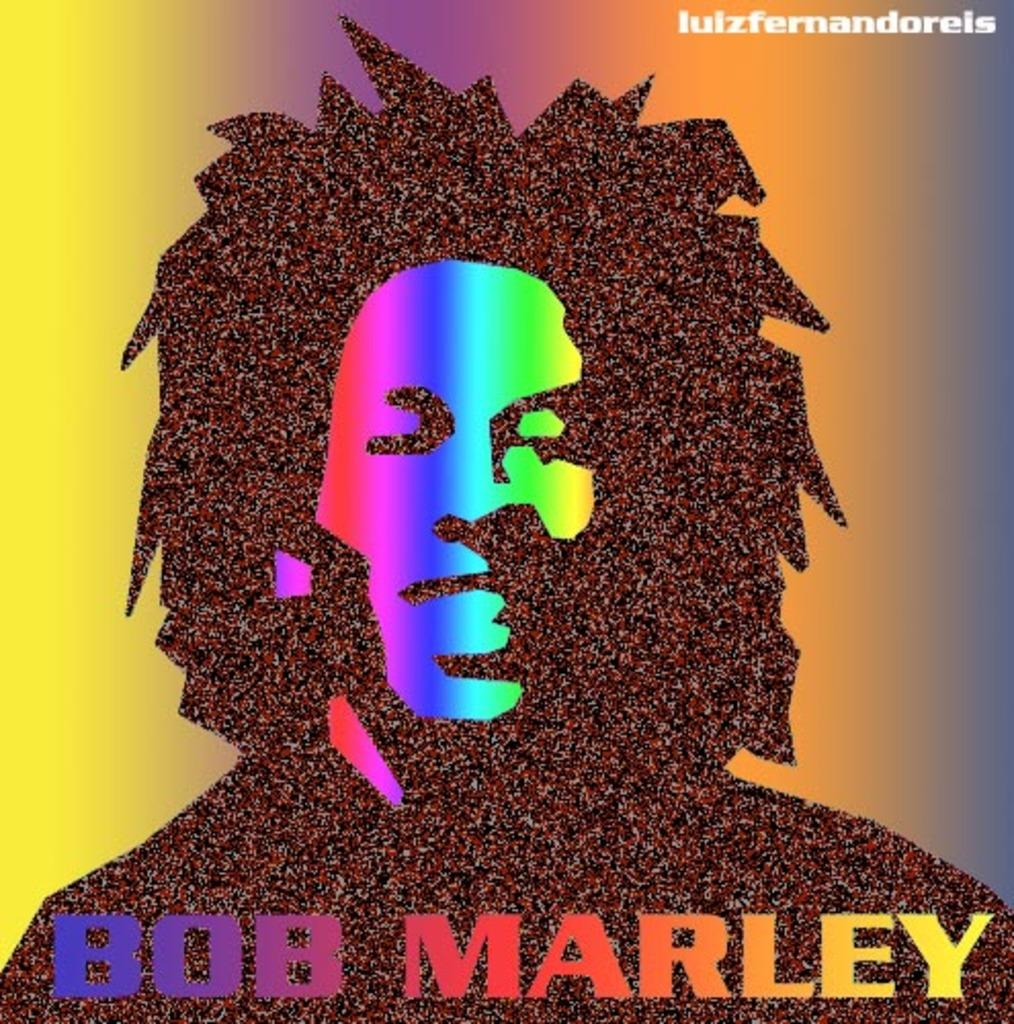Provide a one-sentence caption for the provided image. A very colorful Bob Marley album with a bunch of grain and cool specks. 